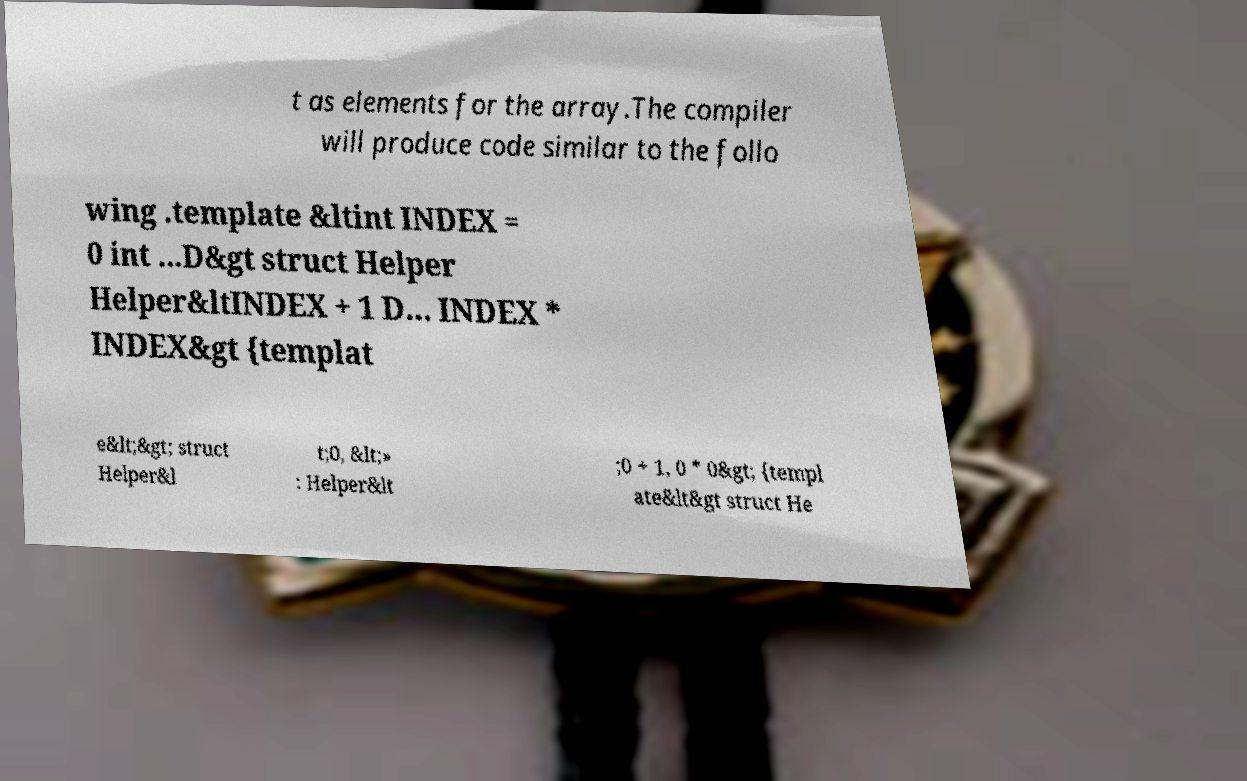Please read and relay the text visible in this image. What does it say? t as elements for the array.The compiler will produce code similar to the follo wing .template &ltint INDEX = 0 int ...D&gt struct Helper Helper&ltINDEX + 1 D... INDEX * INDEX&gt {templat e&lt;&gt; struct Helper&l t;0, &lt;» : Helper&lt ;0 + 1, 0 * 0&gt; {templ ate&lt&gt struct He 